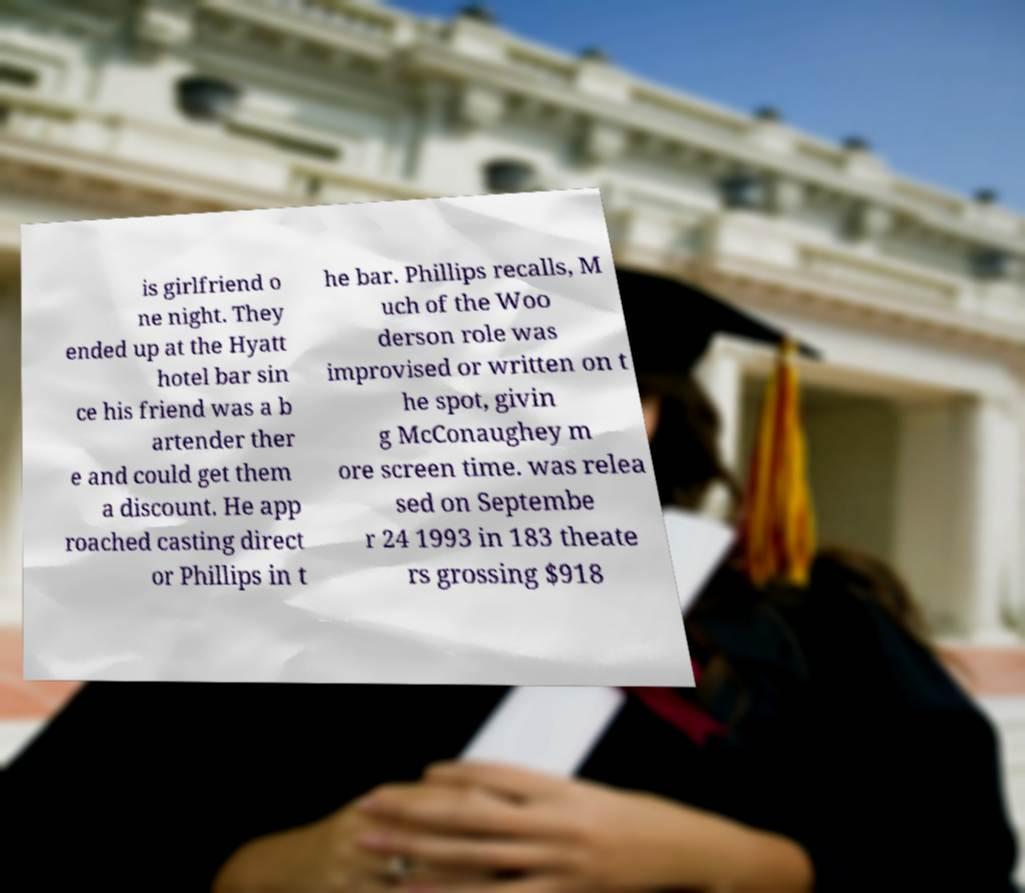What messages or text are displayed in this image? I need them in a readable, typed format. is girlfriend o ne night. They ended up at the Hyatt hotel bar sin ce his friend was a b artender ther e and could get them a discount. He app roached casting direct or Phillips in t he bar. Phillips recalls, M uch of the Woo derson role was improvised or written on t he spot, givin g McConaughey m ore screen time. was relea sed on Septembe r 24 1993 in 183 theate rs grossing $918 